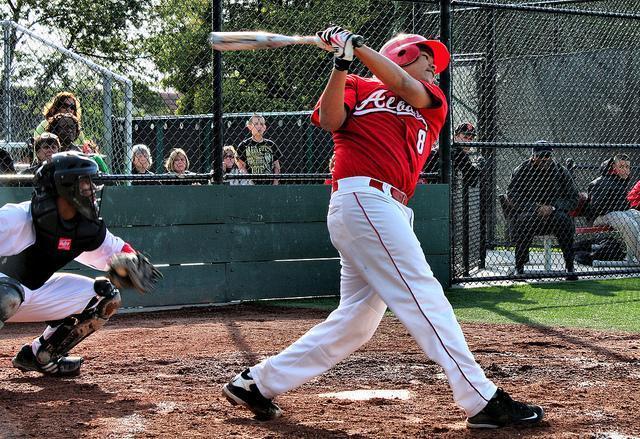How many people are in the photo?
Give a very brief answer. 4. How many bikes are there?
Give a very brief answer. 0. 